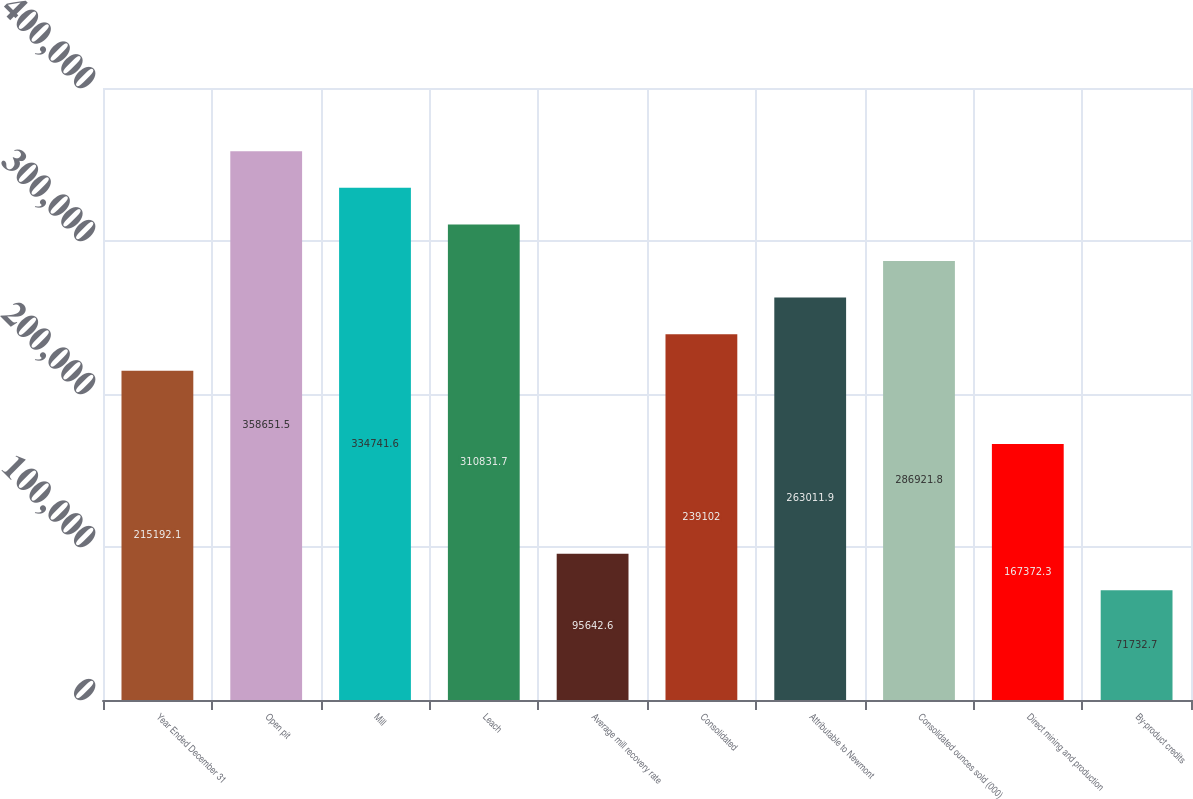Convert chart. <chart><loc_0><loc_0><loc_500><loc_500><bar_chart><fcel>Year Ended December 31<fcel>Open pit<fcel>Mill<fcel>Leach<fcel>Average mill recovery rate<fcel>Consolidated<fcel>Attributable to Newmont<fcel>Consolidated ounces sold (000)<fcel>Direct mining and production<fcel>By-product credits<nl><fcel>215192<fcel>358652<fcel>334742<fcel>310832<fcel>95642.6<fcel>239102<fcel>263012<fcel>286922<fcel>167372<fcel>71732.7<nl></chart> 